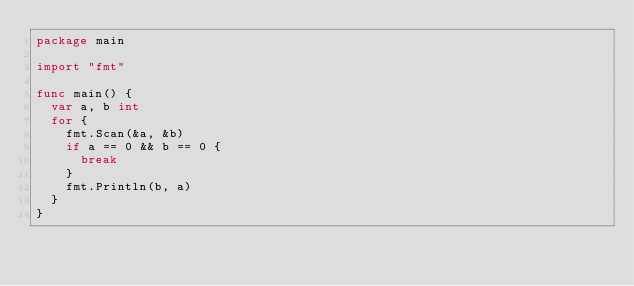<code> <loc_0><loc_0><loc_500><loc_500><_Go_>package main

import "fmt"

func main() {
	var a, b int
	for {
		fmt.Scan(&a, &b)
		if a == 0 && b == 0 {
			break
		}
		fmt.Println(b, a)
	}
}

</code> 